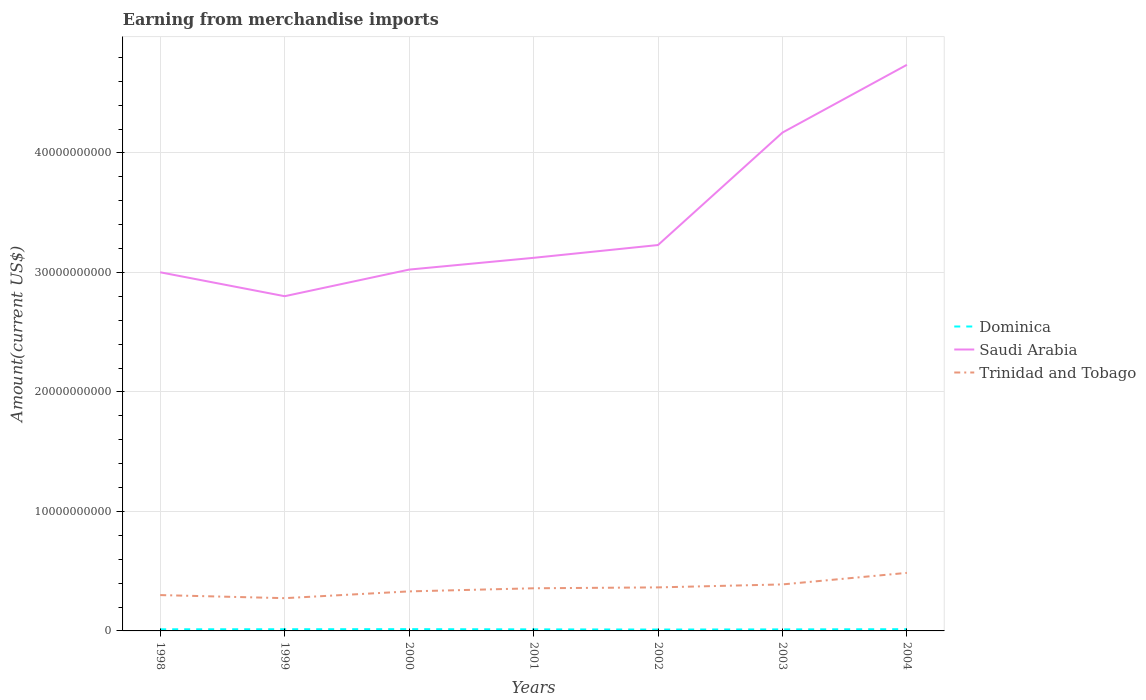How many different coloured lines are there?
Your answer should be compact. 3. Is the number of lines equal to the number of legend labels?
Your answer should be very brief. Yes. Across all years, what is the maximum amount earned from merchandise imports in Trinidad and Tobago?
Offer a very short reply. 2.74e+09. What is the total amount earned from merchandise imports in Saudi Arabia in the graph?
Your answer should be very brief. -5.67e+09. What is the difference between the highest and the second highest amount earned from merchandise imports in Saudi Arabia?
Provide a short and direct response. 1.94e+1. How many lines are there?
Your response must be concise. 3. How many years are there in the graph?
Your response must be concise. 7. Does the graph contain grids?
Your answer should be compact. Yes. How many legend labels are there?
Provide a succinct answer. 3. What is the title of the graph?
Give a very brief answer. Earning from merchandise imports. Does "Gambia, The" appear as one of the legend labels in the graph?
Provide a short and direct response. No. What is the label or title of the Y-axis?
Give a very brief answer. Amount(current US$). What is the Amount(current US$) of Dominica in 1998?
Provide a succinct answer. 1.36e+08. What is the Amount(current US$) of Saudi Arabia in 1998?
Offer a terse response. 3.00e+1. What is the Amount(current US$) in Trinidad and Tobago in 1998?
Your answer should be very brief. 3.00e+09. What is the Amount(current US$) of Dominica in 1999?
Provide a short and direct response. 1.41e+08. What is the Amount(current US$) of Saudi Arabia in 1999?
Your response must be concise. 2.80e+1. What is the Amount(current US$) in Trinidad and Tobago in 1999?
Offer a very short reply. 2.74e+09. What is the Amount(current US$) in Dominica in 2000?
Offer a terse response. 1.48e+08. What is the Amount(current US$) of Saudi Arabia in 2000?
Provide a succinct answer. 3.02e+1. What is the Amount(current US$) in Trinidad and Tobago in 2000?
Keep it short and to the point. 3.31e+09. What is the Amount(current US$) in Dominica in 2001?
Keep it short and to the point. 1.31e+08. What is the Amount(current US$) in Saudi Arabia in 2001?
Your response must be concise. 3.12e+1. What is the Amount(current US$) in Trinidad and Tobago in 2001?
Provide a succinct answer. 3.57e+09. What is the Amount(current US$) of Dominica in 2002?
Ensure brevity in your answer.  1.16e+08. What is the Amount(current US$) of Saudi Arabia in 2002?
Give a very brief answer. 3.23e+1. What is the Amount(current US$) in Trinidad and Tobago in 2002?
Your response must be concise. 3.64e+09. What is the Amount(current US$) in Dominica in 2003?
Offer a very short reply. 1.28e+08. What is the Amount(current US$) of Saudi Arabia in 2003?
Make the answer very short. 4.17e+1. What is the Amount(current US$) in Trinidad and Tobago in 2003?
Your answer should be very brief. 3.89e+09. What is the Amount(current US$) in Dominica in 2004?
Your answer should be very brief. 1.44e+08. What is the Amount(current US$) in Saudi Arabia in 2004?
Offer a very short reply. 4.74e+1. What is the Amount(current US$) of Trinidad and Tobago in 2004?
Provide a succinct answer. 4.86e+09. Across all years, what is the maximum Amount(current US$) in Dominica?
Keep it short and to the point. 1.48e+08. Across all years, what is the maximum Amount(current US$) of Saudi Arabia?
Ensure brevity in your answer.  4.74e+1. Across all years, what is the maximum Amount(current US$) in Trinidad and Tobago?
Your answer should be very brief. 4.86e+09. Across all years, what is the minimum Amount(current US$) of Dominica?
Provide a succinct answer. 1.16e+08. Across all years, what is the minimum Amount(current US$) of Saudi Arabia?
Make the answer very short. 2.80e+1. Across all years, what is the minimum Amount(current US$) in Trinidad and Tobago?
Provide a short and direct response. 2.74e+09. What is the total Amount(current US$) of Dominica in the graph?
Your answer should be compact. 9.44e+08. What is the total Amount(current US$) of Saudi Arabia in the graph?
Make the answer very short. 2.41e+11. What is the total Amount(current US$) of Trinidad and Tobago in the graph?
Provide a short and direct response. 2.50e+1. What is the difference between the Amount(current US$) in Dominica in 1998 and that in 1999?
Offer a very short reply. -5.00e+06. What is the difference between the Amount(current US$) of Saudi Arabia in 1998 and that in 1999?
Your answer should be compact. 2.00e+09. What is the difference between the Amount(current US$) of Trinidad and Tobago in 1998 and that in 1999?
Your answer should be compact. 2.58e+08. What is the difference between the Amount(current US$) of Dominica in 1998 and that in 2000?
Offer a terse response. -1.20e+07. What is the difference between the Amount(current US$) in Saudi Arabia in 1998 and that in 2000?
Provide a succinct answer. -2.25e+08. What is the difference between the Amount(current US$) in Trinidad and Tobago in 1998 and that in 2000?
Give a very brief answer. -3.09e+08. What is the difference between the Amount(current US$) in Saudi Arabia in 1998 and that in 2001?
Your answer should be compact. -1.21e+09. What is the difference between the Amount(current US$) in Trinidad and Tobago in 1998 and that in 2001?
Your response must be concise. -5.70e+08. What is the difference between the Amount(current US$) in Saudi Arabia in 1998 and that in 2002?
Provide a succinct answer. -2.28e+09. What is the difference between the Amount(current US$) of Trinidad and Tobago in 1998 and that in 2002?
Ensure brevity in your answer.  -6.44e+08. What is the difference between the Amount(current US$) in Dominica in 1998 and that in 2003?
Give a very brief answer. 8.05e+06. What is the difference between the Amount(current US$) of Saudi Arabia in 1998 and that in 2003?
Ensure brevity in your answer.  -1.17e+1. What is the difference between the Amount(current US$) of Trinidad and Tobago in 1998 and that in 2003?
Your answer should be very brief. -8.93e+08. What is the difference between the Amount(current US$) in Dominica in 1998 and that in 2004?
Make the answer very short. -8.41e+06. What is the difference between the Amount(current US$) of Saudi Arabia in 1998 and that in 2004?
Give a very brief answer. -1.74e+1. What is the difference between the Amount(current US$) in Trinidad and Tobago in 1998 and that in 2004?
Your response must be concise. -1.86e+09. What is the difference between the Amount(current US$) in Dominica in 1999 and that in 2000?
Offer a very short reply. -7.00e+06. What is the difference between the Amount(current US$) of Saudi Arabia in 1999 and that in 2000?
Your answer should be compact. -2.23e+09. What is the difference between the Amount(current US$) of Trinidad and Tobago in 1999 and that in 2000?
Keep it short and to the point. -5.67e+08. What is the difference between the Amount(current US$) in Dominica in 1999 and that in 2001?
Offer a terse response. 1.00e+07. What is the difference between the Amount(current US$) of Saudi Arabia in 1999 and that in 2001?
Ensure brevity in your answer.  -3.21e+09. What is the difference between the Amount(current US$) of Trinidad and Tobago in 1999 and that in 2001?
Give a very brief answer. -8.28e+08. What is the difference between the Amount(current US$) of Dominica in 1999 and that in 2002?
Your answer should be compact. 2.50e+07. What is the difference between the Amount(current US$) of Saudi Arabia in 1999 and that in 2002?
Your answer should be compact. -4.28e+09. What is the difference between the Amount(current US$) in Trinidad and Tobago in 1999 and that in 2002?
Offer a very short reply. -9.02e+08. What is the difference between the Amount(current US$) of Dominica in 1999 and that in 2003?
Your answer should be compact. 1.31e+07. What is the difference between the Amount(current US$) in Saudi Arabia in 1999 and that in 2003?
Provide a short and direct response. -1.37e+1. What is the difference between the Amount(current US$) in Trinidad and Tobago in 1999 and that in 2003?
Give a very brief answer. -1.15e+09. What is the difference between the Amount(current US$) of Dominica in 1999 and that in 2004?
Make the answer very short. -3.41e+06. What is the difference between the Amount(current US$) of Saudi Arabia in 1999 and that in 2004?
Give a very brief answer. -1.94e+1. What is the difference between the Amount(current US$) in Trinidad and Tobago in 1999 and that in 2004?
Your answer should be very brief. -2.12e+09. What is the difference between the Amount(current US$) in Dominica in 2000 and that in 2001?
Make the answer very short. 1.70e+07. What is the difference between the Amount(current US$) in Saudi Arabia in 2000 and that in 2001?
Your answer should be compact. -9.85e+08. What is the difference between the Amount(current US$) in Trinidad and Tobago in 2000 and that in 2001?
Your response must be concise. -2.61e+08. What is the difference between the Amount(current US$) in Dominica in 2000 and that in 2002?
Make the answer very short. 3.20e+07. What is the difference between the Amount(current US$) in Saudi Arabia in 2000 and that in 2002?
Your response must be concise. -2.06e+09. What is the difference between the Amount(current US$) in Trinidad and Tobago in 2000 and that in 2002?
Your answer should be compact. -3.35e+08. What is the difference between the Amount(current US$) of Dominica in 2000 and that in 2003?
Provide a short and direct response. 2.01e+07. What is the difference between the Amount(current US$) of Saudi Arabia in 2000 and that in 2003?
Give a very brief answer. -1.15e+1. What is the difference between the Amount(current US$) of Trinidad and Tobago in 2000 and that in 2003?
Offer a terse response. -5.84e+08. What is the difference between the Amount(current US$) in Dominica in 2000 and that in 2004?
Ensure brevity in your answer.  3.59e+06. What is the difference between the Amount(current US$) of Saudi Arabia in 2000 and that in 2004?
Make the answer very short. -1.71e+1. What is the difference between the Amount(current US$) of Trinidad and Tobago in 2000 and that in 2004?
Offer a terse response. -1.55e+09. What is the difference between the Amount(current US$) of Dominica in 2001 and that in 2002?
Offer a very short reply. 1.50e+07. What is the difference between the Amount(current US$) in Saudi Arabia in 2001 and that in 2002?
Ensure brevity in your answer.  -1.07e+09. What is the difference between the Amount(current US$) in Trinidad and Tobago in 2001 and that in 2002?
Give a very brief answer. -7.40e+07. What is the difference between the Amount(current US$) of Dominica in 2001 and that in 2003?
Make the answer very short. 3.05e+06. What is the difference between the Amount(current US$) of Saudi Arabia in 2001 and that in 2003?
Your answer should be very brief. -1.05e+1. What is the difference between the Amount(current US$) in Trinidad and Tobago in 2001 and that in 2003?
Offer a terse response. -3.23e+08. What is the difference between the Amount(current US$) of Dominica in 2001 and that in 2004?
Provide a short and direct response. -1.34e+07. What is the difference between the Amount(current US$) in Saudi Arabia in 2001 and that in 2004?
Make the answer very short. -1.62e+1. What is the difference between the Amount(current US$) of Trinidad and Tobago in 2001 and that in 2004?
Provide a short and direct response. -1.29e+09. What is the difference between the Amount(current US$) in Dominica in 2002 and that in 2003?
Your answer should be very brief. -1.19e+07. What is the difference between the Amount(current US$) in Saudi Arabia in 2002 and that in 2003?
Offer a terse response. -9.41e+09. What is the difference between the Amount(current US$) in Trinidad and Tobago in 2002 and that in 2003?
Provide a succinct answer. -2.49e+08. What is the difference between the Amount(current US$) of Dominica in 2002 and that in 2004?
Your response must be concise. -2.84e+07. What is the difference between the Amount(current US$) in Saudi Arabia in 2002 and that in 2004?
Offer a very short reply. -1.51e+1. What is the difference between the Amount(current US$) of Trinidad and Tobago in 2002 and that in 2004?
Ensure brevity in your answer.  -1.22e+09. What is the difference between the Amount(current US$) in Dominica in 2003 and that in 2004?
Offer a terse response. -1.65e+07. What is the difference between the Amount(current US$) of Saudi Arabia in 2003 and that in 2004?
Ensure brevity in your answer.  -5.67e+09. What is the difference between the Amount(current US$) in Trinidad and Tobago in 2003 and that in 2004?
Make the answer very short. -9.66e+08. What is the difference between the Amount(current US$) in Dominica in 1998 and the Amount(current US$) in Saudi Arabia in 1999?
Offer a terse response. -2.79e+1. What is the difference between the Amount(current US$) of Dominica in 1998 and the Amount(current US$) of Trinidad and Tobago in 1999?
Provide a succinct answer. -2.60e+09. What is the difference between the Amount(current US$) of Saudi Arabia in 1998 and the Amount(current US$) of Trinidad and Tobago in 1999?
Your answer should be compact. 2.73e+1. What is the difference between the Amount(current US$) of Dominica in 1998 and the Amount(current US$) of Saudi Arabia in 2000?
Provide a short and direct response. -3.01e+1. What is the difference between the Amount(current US$) in Dominica in 1998 and the Amount(current US$) in Trinidad and Tobago in 2000?
Keep it short and to the point. -3.17e+09. What is the difference between the Amount(current US$) of Saudi Arabia in 1998 and the Amount(current US$) of Trinidad and Tobago in 2000?
Your response must be concise. 2.67e+1. What is the difference between the Amount(current US$) in Dominica in 1998 and the Amount(current US$) in Saudi Arabia in 2001?
Your answer should be compact. -3.11e+1. What is the difference between the Amount(current US$) of Dominica in 1998 and the Amount(current US$) of Trinidad and Tobago in 2001?
Keep it short and to the point. -3.43e+09. What is the difference between the Amount(current US$) in Saudi Arabia in 1998 and the Amount(current US$) in Trinidad and Tobago in 2001?
Offer a very short reply. 2.64e+1. What is the difference between the Amount(current US$) of Dominica in 1998 and the Amount(current US$) of Saudi Arabia in 2002?
Make the answer very short. -3.22e+1. What is the difference between the Amount(current US$) of Dominica in 1998 and the Amount(current US$) of Trinidad and Tobago in 2002?
Your answer should be compact. -3.51e+09. What is the difference between the Amount(current US$) in Saudi Arabia in 1998 and the Amount(current US$) in Trinidad and Tobago in 2002?
Provide a short and direct response. 2.64e+1. What is the difference between the Amount(current US$) in Dominica in 1998 and the Amount(current US$) in Saudi Arabia in 2003?
Provide a short and direct response. -4.16e+1. What is the difference between the Amount(current US$) in Dominica in 1998 and the Amount(current US$) in Trinidad and Tobago in 2003?
Your answer should be compact. -3.76e+09. What is the difference between the Amount(current US$) in Saudi Arabia in 1998 and the Amount(current US$) in Trinidad and Tobago in 2003?
Your response must be concise. 2.61e+1. What is the difference between the Amount(current US$) in Dominica in 1998 and the Amount(current US$) in Saudi Arabia in 2004?
Your answer should be compact. -4.72e+1. What is the difference between the Amount(current US$) in Dominica in 1998 and the Amount(current US$) in Trinidad and Tobago in 2004?
Provide a short and direct response. -4.72e+09. What is the difference between the Amount(current US$) in Saudi Arabia in 1998 and the Amount(current US$) in Trinidad and Tobago in 2004?
Your answer should be very brief. 2.52e+1. What is the difference between the Amount(current US$) in Dominica in 1999 and the Amount(current US$) in Saudi Arabia in 2000?
Offer a terse response. -3.01e+1. What is the difference between the Amount(current US$) in Dominica in 1999 and the Amount(current US$) in Trinidad and Tobago in 2000?
Offer a very short reply. -3.17e+09. What is the difference between the Amount(current US$) of Saudi Arabia in 1999 and the Amount(current US$) of Trinidad and Tobago in 2000?
Make the answer very short. 2.47e+1. What is the difference between the Amount(current US$) of Dominica in 1999 and the Amount(current US$) of Saudi Arabia in 2001?
Give a very brief answer. -3.11e+1. What is the difference between the Amount(current US$) in Dominica in 1999 and the Amount(current US$) in Trinidad and Tobago in 2001?
Offer a terse response. -3.43e+09. What is the difference between the Amount(current US$) in Saudi Arabia in 1999 and the Amount(current US$) in Trinidad and Tobago in 2001?
Ensure brevity in your answer.  2.44e+1. What is the difference between the Amount(current US$) in Dominica in 1999 and the Amount(current US$) in Saudi Arabia in 2002?
Give a very brief answer. -3.22e+1. What is the difference between the Amount(current US$) of Dominica in 1999 and the Amount(current US$) of Trinidad and Tobago in 2002?
Provide a short and direct response. -3.50e+09. What is the difference between the Amount(current US$) of Saudi Arabia in 1999 and the Amount(current US$) of Trinidad and Tobago in 2002?
Provide a succinct answer. 2.44e+1. What is the difference between the Amount(current US$) of Dominica in 1999 and the Amount(current US$) of Saudi Arabia in 2003?
Your answer should be compact. -4.16e+1. What is the difference between the Amount(current US$) of Dominica in 1999 and the Amount(current US$) of Trinidad and Tobago in 2003?
Ensure brevity in your answer.  -3.75e+09. What is the difference between the Amount(current US$) in Saudi Arabia in 1999 and the Amount(current US$) in Trinidad and Tobago in 2003?
Provide a succinct answer. 2.41e+1. What is the difference between the Amount(current US$) in Dominica in 1999 and the Amount(current US$) in Saudi Arabia in 2004?
Your answer should be compact. -4.72e+1. What is the difference between the Amount(current US$) in Dominica in 1999 and the Amount(current US$) in Trinidad and Tobago in 2004?
Provide a succinct answer. -4.72e+09. What is the difference between the Amount(current US$) in Saudi Arabia in 1999 and the Amount(current US$) in Trinidad and Tobago in 2004?
Keep it short and to the point. 2.32e+1. What is the difference between the Amount(current US$) in Dominica in 2000 and the Amount(current US$) in Saudi Arabia in 2001?
Your answer should be very brief. -3.11e+1. What is the difference between the Amount(current US$) in Dominica in 2000 and the Amount(current US$) in Trinidad and Tobago in 2001?
Provide a short and direct response. -3.42e+09. What is the difference between the Amount(current US$) of Saudi Arabia in 2000 and the Amount(current US$) of Trinidad and Tobago in 2001?
Ensure brevity in your answer.  2.67e+1. What is the difference between the Amount(current US$) of Dominica in 2000 and the Amount(current US$) of Saudi Arabia in 2002?
Your answer should be compact. -3.21e+1. What is the difference between the Amount(current US$) in Dominica in 2000 and the Amount(current US$) in Trinidad and Tobago in 2002?
Give a very brief answer. -3.50e+09. What is the difference between the Amount(current US$) in Saudi Arabia in 2000 and the Amount(current US$) in Trinidad and Tobago in 2002?
Your answer should be compact. 2.66e+1. What is the difference between the Amount(current US$) of Dominica in 2000 and the Amount(current US$) of Saudi Arabia in 2003?
Your answer should be compact. -4.16e+1. What is the difference between the Amount(current US$) in Dominica in 2000 and the Amount(current US$) in Trinidad and Tobago in 2003?
Your answer should be very brief. -3.74e+09. What is the difference between the Amount(current US$) in Saudi Arabia in 2000 and the Amount(current US$) in Trinidad and Tobago in 2003?
Give a very brief answer. 2.63e+1. What is the difference between the Amount(current US$) of Dominica in 2000 and the Amount(current US$) of Saudi Arabia in 2004?
Offer a terse response. -4.72e+1. What is the difference between the Amount(current US$) in Dominica in 2000 and the Amount(current US$) in Trinidad and Tobago in 2004?
Offer a terse response. -4.71e+09. What is the difference between the Amount(current US$) in Saudi Arabia in 2000 and the Amount(current US$) in Trinidad and Tobago in 2004?
Your answer should be very brief. 2.54e+1. What is the difference between the Amount(current US$) of Dominica in 2001 and the Amount(current US$) of Saudi Arabia in 2002?
Offer a terse response. -3.22e+1. What is the difference between the Amount(current US$) in Dominica in 2001 and the Amount(current US$) in Trinidad and Tobago in 2002?
Keep it short and to the point. -3.51e+09. What is the difference between the Amount(current US$) of Saudi Arabia in 2001 and the Amount(current US$) of Trinidad and Tobago in 2002?
Offer a very short reply. 2.76e+1. What is the difference between the Amount(current US$) of Dominica in 2001 and the Amount(current US$) of Saudi Arabia in 2003?
Keep it short and to the point. -4.16e+1. What is the difference between the Amount(current US$) of Dominica in 2001 and the Amount(current US$) of Trinidad and Tobago in 2003?
Offer a very short reply. -3.76e+09. What is the difference between the Amount(current US$) in Saudi Arabia in 2001 and the Amount(current US$) in Trinidad and Tobago in 2003?
Your answer should be compact. 2.73e+1. What is the difference between the Amount(current US$) in Dominica in 2001 and the Amount(current US$) in Saudi Arabia in 2004?
Give a very brief answer. -4.72e+1. What is the difference between the Amount(current US$) of Dominica in 2001 and the Amount(current US$) of Trinidad and Tobago in 2004?
Provide a succinct answer. -4.73e+09. What is the difference between the Amount(current US$) of Saudi Arabia in 2001 and the Amount(current US$) of Trinidad and Tobago in 2004?
Provide a short and direct response. 2.64e+1. What is the difference between the Amount(current US$) in Dominica in 2002 and the Amount(current US$) in Saudi Arabia in 2003?
Keep it short and to the point. -4.16e+1. What is the difference between the Amount(current US$) in Dominica in 2002 and the Amount(current US$) in Trinidad and Tobago in 2003?
Provide a succinct answer. -3.78e+09. What is the difference between the Amount(current US$) in Saudi Arabia in 2002 and the Amount(current US$) in Trinidad and Tobago in 2003?
Keep it short and to the point. 2.84e+1. What is the difference between the Amount(current US$) in Dominica in 2002 and the Amount(current US$) in Saudi Arabia in 2004?
Ensure brevity in your answer.  -4.73e+1. What is the difference between the Amount(current US$) of Dominica in 2002 and the Amount(current US$) of Trinidad and Tobago in 2004?
Give a very brief answer. -4.74e+09. What is the difference between the Amount(current US$) in Saudi Arabia in 2002 and the Amount(current US$) in Trinidad and Tobago in 2004?
Make the answer very short. 2.74e+1. What is the difference between the Amount(current US$) in Dominica in 2003 and the Amount(current US$) in Saudi Arabia in 2004?
Give a very brief answer. -4.72e+1. What is the difference between the Amount(current US$) of Dominica in 2003 and the Amount(current US$) of Trinidad and Tobago in 2004?
Make the answer very short. -4.73e+09. What is the difference between the Amount(current US$) of Saudi Arabia in 2003 and the Amount(current US$) of Trinidad and Tobago in 2004?
Ensure brevity in your answer.  3.68e+1. What is the average Amount(current US$) in Dominica per year?
Provide a short and direct response. 1.35e+08. What is the average Amount(current US$) of Saudi Arabia per year?
Offer a terse response. 3.44e+1. What is the average Amount(current US$) in Trinidad and Tobago per year?
Offer a very short reply. 3.57e+09. In the year 1998, what is the difference between the Amount(current US$) of Dominica and Amount(current US$) of Saudi Arabia?
Keep it short and to the point. -2.99e+1. In the year 1998, what is the difference between the Amount(current US$) in Dominica and Amount(current US$) in Trinidad and Tobago?
Provide a succinct answer. -2.86e+09. In the year 1998, what is the difference between the Amount(current US$) of Saudi Arabia and Amount(current US$) of Trinidad and Tobago?
Your answer should be compact. 2.70e+1. In the year 1999, what is the difference between the Amount(current US$) of Dominica and Amount(current US$) of Saudi Arabia?
Give a very brief answer. -2.79e+1. In the year 1999, what is the difference between the Amount(current US$) of Dominica and Amount(current US$) of Trinidad and Tobago?
Offer a very short reply. -2.60e+09. In the year 1999, what is the difference between the Amount(current US$) in Saudi Arabia and Amount(current US$) in Trinidad and Tobago?
Keep it short and to the point. 2.53e+1. In the year 2000, what is the difference between the Amount(current US$) of Dominica and Amount(current US$) of Saudi Arabia?
Keep it short and to the point. -3.01e+1. In the year 2000, what is the difference between the Amount(current US$) in Dominica and Amount(current US$) in Trinidad and Tobago?
Offer a very short reply. -3.16e+09. In the year 2000, what is the difference between the Amount(current US$) in Saudi Arabia and Amount(current US$) in Trinidad and Tobago?
Your answer should be compact. 2.69e+1. In the year 2001, what is the difference between the Amount(current US$) in Dominica and Amount(current US$) in Saudi Arabia?
Your answer should be very brief. -3.11e+1. In the year 2001, what is the difference between the Amount(current US$) in Dominica and Amount(current US$) in Trinidad and Tobago?
Provide a short and direct response. -3.44e+09. In the year 2001, what is the difference between the Amount(current US$) of Saudi Arabia and Amount(current US$) of Trinidad and Tobago?
Give a very brief answer. 2.77e+1. In the year 2002, what is the difference between the Amount(current US$) in Dominica and Amount(current US$) in Saudi Arabia?
Ensure brevity in your answer.  -3.22e+1. In the year 2002, what is the difference between the Amount(current US$) of Dominica and Amount(current US$) of Trinidad and Tobago?
Your answer should be compact. -3.53e+09. In the year 2002, what is the difference between the Amount(current US$) of Saudi Arabia and Amount(current US$) of Trinidad and Tobago?
Your answer should be compact. 2.87e+1. In the year 2003, what is the difference between the Amount(current US$) in Dominica and Amount(current US$) in Saudi Arabia?
Ensure brevity in your answer.  -4.16e+1. In the year 2003, what is the difference between the Amount(current US$) of Dominica and Amount(current US$) of Trinidad and Tobago?
Your answer should be compact. -3.76e+09. In the year 2003, what is the difference between the Amount(current US$) in Saudi Arabia and Amount(current US$) in Trinidad and Tobago?
Provide a short and direct response. 3.78e+1. In the year 2004, what is the difference between the Amount(current US$) of Dominica and Amount(current US$) of Saudi Arabia?
Keep it short and to the point. -4.72e+1. In the year 2004, what is the difference between the Amount(current US$) of Dominica and Amount(current US$) of Trinidad and Tobago?
Your answer should be compact. -4.71e+09. In the year 2004, what is the difference between the Amount(current US$) in Saudi Arabia and Amount(current US$) in Trinidad and Tobago?
Your answer should be compact. 4.25e+1. What is the ratio of the Amount(current US$) of Dominica in 1998 to that in 1999?
Make the answer very short. 0.96. What is the ratio of the Amount(current US$) in Saudi Arabia in 1998 to that in 1999?
Provide a short and direct response. 1.07. What is the ratio of the Amount(current US$) in Trinidad and Tobago in 1998 to that in 1999?
Offer a terse response. 1.09. What is the ratio of the Amount(current US$) in Dominica in 1998 to that in 2000?
Offer a very short reply. 0.92. What is the ratio of the Amount(current US$) of Trinidad and Tobago in 1998 to that in 2000?
Offer a very short reply. 0.91. What is the ratio of the Amount(current US$) in Dominica in 1998 to that in 2001?
Offer a very short reply. 1.04. What is the ratio of the Amount(current US$) of Saudi Arabia in 1998 to that in 2001?
Give a very brief answer. 0.96. What is the ratio of the Amount(current US$) in Trinidad and Tobago in 1998 to that in 2001?
Your answer should be very brief. 0.84. What is the ratio of the Amount(current US$) of Dominica in 1998 to that in 2002?
Your answer should be compact. 1.17. What is the ratio of the Amount(current US$) in Saudi Arabia in 1998 to that in 2002?
Your response must be concise. 0.93. What is the ratio of the Amount(current US$) of Trinidad and Tobago in 1998 to that in 2002?
Make the answer very short. 0.82. What is the ratio of the Amount(current US$) in Dominica in 1998 to that in 2003?
Give a very brief answer. 1.06. What is the ratio of the Amount(current US$) in Saudi Arabia in 1998 to that in 2003?
Offer a very short reply. 0.72. What is the ratio of the Amount(current US$) of Trinidad and Tobago in 1998 to that in 2003?
Provide a succinct answer. 0.77. What is the ratio of the Amount(current US$) in Dominica in 1998 to that in 2004?
Keep it short and to the point. 0.94. What is the ratio of the Amount(current US$) in Saudi Arabia in 1998 to that in 2004?
Ensure brevity in your answer.  0.63. What is the ratio of the Amount(current US$) in Trinidad and Tobago in 1998 to that in 2004?
Provide a succinct answer. 0.62. What is the ratio of the Amount(current US$) of Dominica in 1999 to that in 2000?
Give a very brief answer. 0.95. What is the ratio of the Amount(current US$) in Saudi Arabia in 1999 to that in 2000?
Offer a terse response. 0.93. What is the ratio of the Amount(current US$) of Trinidad and Tobago in 1999 to that in 2000?
Provide a short and direct response. 0.83. What is the ratio of the Amount(current US$) of Dominica in 1999 to that in 2001?
Your response must be concise. 1.08. What is the ratio of the Amount(current US$) in Saudi Arabia in 1999 to that in 2001?
Keep it short and to the point. 0.9. What is the ratio of the Amount(current US$) in Trinidad and Tobago in 1999 to that in 2001?
Your response must be concise. 0.77. What is the ratio of the Amount(current US$) in Dominica in 1999 to that in 2002?
Offer a terse response. 1.22. What is the ratio of the Amount(current US$) in Saudi Arabia in 1999 to that in 2002?
Ensure brevity in your answer.  0.87. What is the ratio of the Amount(current US$) in Trinidad and Tobago in 1999 to that in 2002?
Make the answer very short. 0.75. What is the ratio of the Amount(current US$) in Dominica in 1999 to that in 2003?
Ensure brevity in your answer.  1.1. What is the ratio of the Amount(current US$) in Saudi Arabia in 1999 to that in 2003?
Provide a succinct answer. 0.67. What is the ratio of the Amount(current US$) in Trinidad and Tobago in 1999 to that in 2003?
Ensure brevity in your answer.  0.7. What is the ratio of the Amount(current US$) of Dominica in 1999 to that in 2004?
Your answer should be compact. 0.98. What is the ratio of the Amount(current US$) of Saudi Arabia in 1999 to that in 2004?
Make the answer very short. 0.59. What is the ratio of the Amount(current US$) in Trinidad and Tobago in 1999 to that in 2004?
Your answer should be very brief. 0.56. What is the ratio of the Amount(current US$) in Dominica in 2000 to that in 2001?
Make the answer very short. 1.13. What is the ratio of the Amount(current US$) of Saudi Arabia in 2000 to that in 2001?
Provide a short and direct response. 0.97. What is the ratio of the Amount(current US$) in Trinidad and Tobago in 2000 to that in 2001?
Give a very brief answer. 0.93. What is the ratio of the Amount(current US$) of Dominica in 2000 to that in 2002?
Offer a very short reply. 1.28. What is the ratio of the Amount(current US$) in Saudi Arabia in 2000 to that in 2002?
Keep it short and to the point. 0.94. What is the ratio of the Amount(current US$) of Trinidad and Tobago in 2000 to that in 2002?
Your answer should be very brief. 0.91. What is the ratio of the Amount(current US$) in Dominica in 2000 to that in 2003?
Provide a short and direct response. 1.16. What is the ratio of the Amount(current US$) of Saudi Arabia in 2000 to that in 2003?
Provide a short and direct response. 0.73. What is the ratio of the Amount(current US$) of Trinidad and Tobago in 2000 to that in 2003?
Your response must be concise. 0.85. What is the ratio of the Amount(current US$) of Dominica in 2000 to that in 2004?
Ensure brevity in your answer.  1.02. What is the ratio of the Amount(current US$) of Saudi Arabia in 2000 to that in 2004?
Your answer should be very brief. 0.64. What is the ratio of the Amount(current US$) of Trinidad and Tobago in 2000 to that in 2004?
Ensure brevity in your answer.  0.68. What is the ratio of the Amount(current US$) of Dominica in 2001 to that in 2002?
Give a very brief answer. 1.13. What is the ratio of the Amount(current US$) of Saudi Arabia in 2001 to that in 2002?
Offer a very short reply. 0.97. What is the ratio of the Amount(current US$) in Trinidad and Tobago in 2001 to that in 2002?
Your answer should be very brief. 0.98. What is the ratio of the Amount(current US$) in Dominica in 2001 to that in 2003?
Provide a short and direct response. 1.02. What is the ratio of the Amount(current US$) in Saudi Arabia in 2001 to that in 2003?
Offer a terse response. 0.75. What is the ratio of the Amount(current US$) in Trinidad and Tobago in 2001 to that in 2003?
Your response must be concise. 0.92. What is the ratio of the Amount(current US$) of Dominica in 2001 to that in 2004?
Ensure brevity in your answer.  0.91. What is the ratio of the Amount(current US$) of Saudi Arabia in 2001 to that in 2004?
Give a very brief answer. 0.66. What is the ratio of the Amount(current US$) of Trinidad and Tobago in 2001 to that in 2004?
Provide a succinct answer. 0.73. What is the ratio of the Amount(current US$) in Dominica in 2002 to that in 2003?
Provide a succinct answer. 0.91. What is the ratio of the Amount(current US$) in Saudi Arabia in 2002 to that in 2003?
Keep it short and to the point. 0.77. What is the ratio of the Amount(current US$) in Trinidad and Tobago in 2002 to that in 2003?
Offer a very short reply. 0.94. What is the ratio of the Amount(current US$) of Dominica in 2002 to that in 2004?
Ensure brevity in your answer.  0.8. What is the ratio of the Amount(current US$) in Saudi Arabia in 2002 to that in 2004?
Ensure brevity in your answer.  0.68. What is the ratio of the Amount(current US$) in Trinidad and Tobago in 2002 to that in 2004?
Your response must be concise. 0.75. What is the ratio of the Amount(current US$) in Dominica in 2003 to that in 2004?
Provide a succinct answer. 0.89. What is the ratio of the Amount(current US$) of Saudi Arabia in 2003 to that in 2004?
Ensure brevity in your answer.  0.88. What is the ratio of the Amount(current US$) in Trinidad and Tobago in 2003 to that in 2004?
Ensure brevity in your answer.  0.8. What is the difference between the highest and the second highest Amount(current US$) in Dominica?
Offer a very short reply. 3.59e+06. What is the difference between the highest and the second highest Amount(current US$) in Saudi Arabia?
Your answer should be compact. 5.67e+09. What is the difference between the highest and the second highest Amount(current US$) in Trinidad and Tobago?
Ensure brevity in your answer.  9.66e+08. What is the difference between the highest and the lowest Amount(current US$) in Dominica?
Your response must be concise. 3.20e+07. What is the difference between the highest and the lowest Amount(current US$) in Saudi Arabia?
Provide a short and direct response. 1.94e+1. What is the difference between the highest and the lowest Amount(current US$) of Trinidad and Tobago?
Provide a succinct answer. 2.12e+09. 